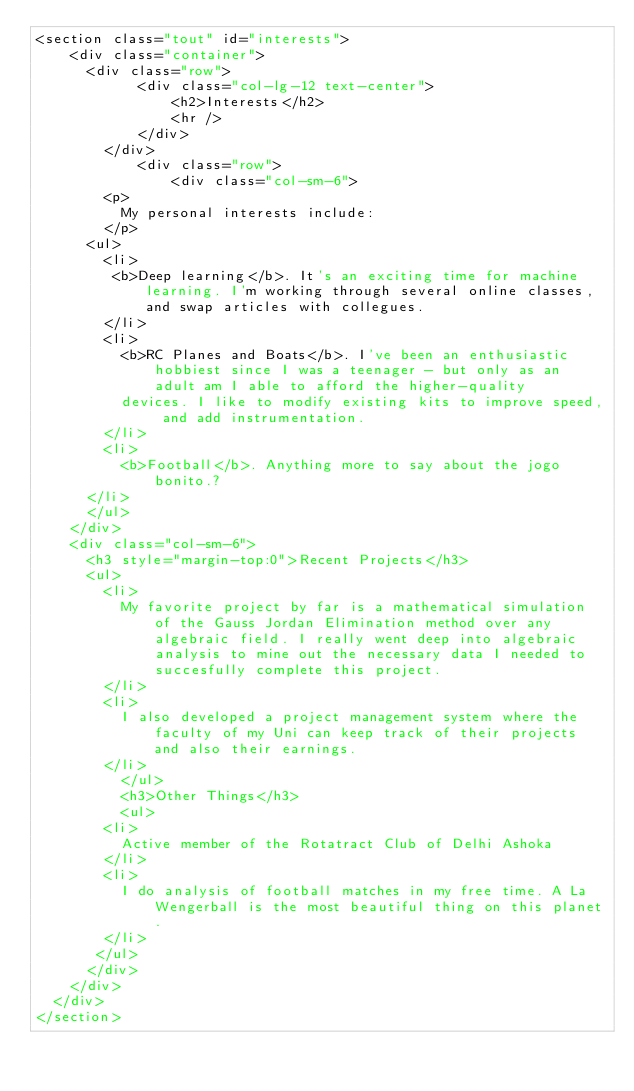Convert code to text. <code><loc_0><loc_0><loc_500><loc_500><_HTML_><section class="tout" id="interests">
    <div class="container">
      <div class="row">
            <div class="col-lg-12 text-center">
                <h2>Interests</h2>
                <hr />
            </div>
        </div>
            <div class="row">
                <div class="col-sm-6">
		    <p>
			    My personal interests include:
        </p>
			<ul>
			  <li>
				 <b>Deep learning</b>. It's an exciting time for machine learning. I'm working through several online classes, and swap articles with collegues.
			  </li>
			  <li>
				  <b>RC Planes and Boats</b>. I've been an enthusiastic hobbiest since I was a teenager - but only as an adult am I able to afford the higher-quality
          devices. I like to modify existing kits to improve speed, and add instrumentation.
			  </li>
			  <li>
				  <b>Football</b>. Anything more to say about the jogo bonito.?      
      </li>
			</ul>
		</div>
    <div class="col-sm-6">
      <h3 style="margin-top:0">Recent Projects</h3>
		  <ul>
  			<li>
          My favorite project by far is a mathematical simulation of the Gauss Jordan Elimination method over any algebraic field. I really went deep into algebraic analysis to mine out the necessary data I needed to succesfully complete this project.
    		</li>
  			<li>
          I also developed a project management system where the faculty of my Uni can keep track of their projects and also their earnings.
  			</li>
  		    </ul>
  		    <h3>Other Things</h3>
  		    <ul>
  			<li>
          Active member of the Rotatract Club of Delhi Ashoka
  			</li>
  			<li>
  			  I do analysis of football matches in my free time. A La Wengerball is the most beautiful thing on this planet.
  			</li>
		   </ul>
      </div>
    </div>
  </div>
</section>
</code> 